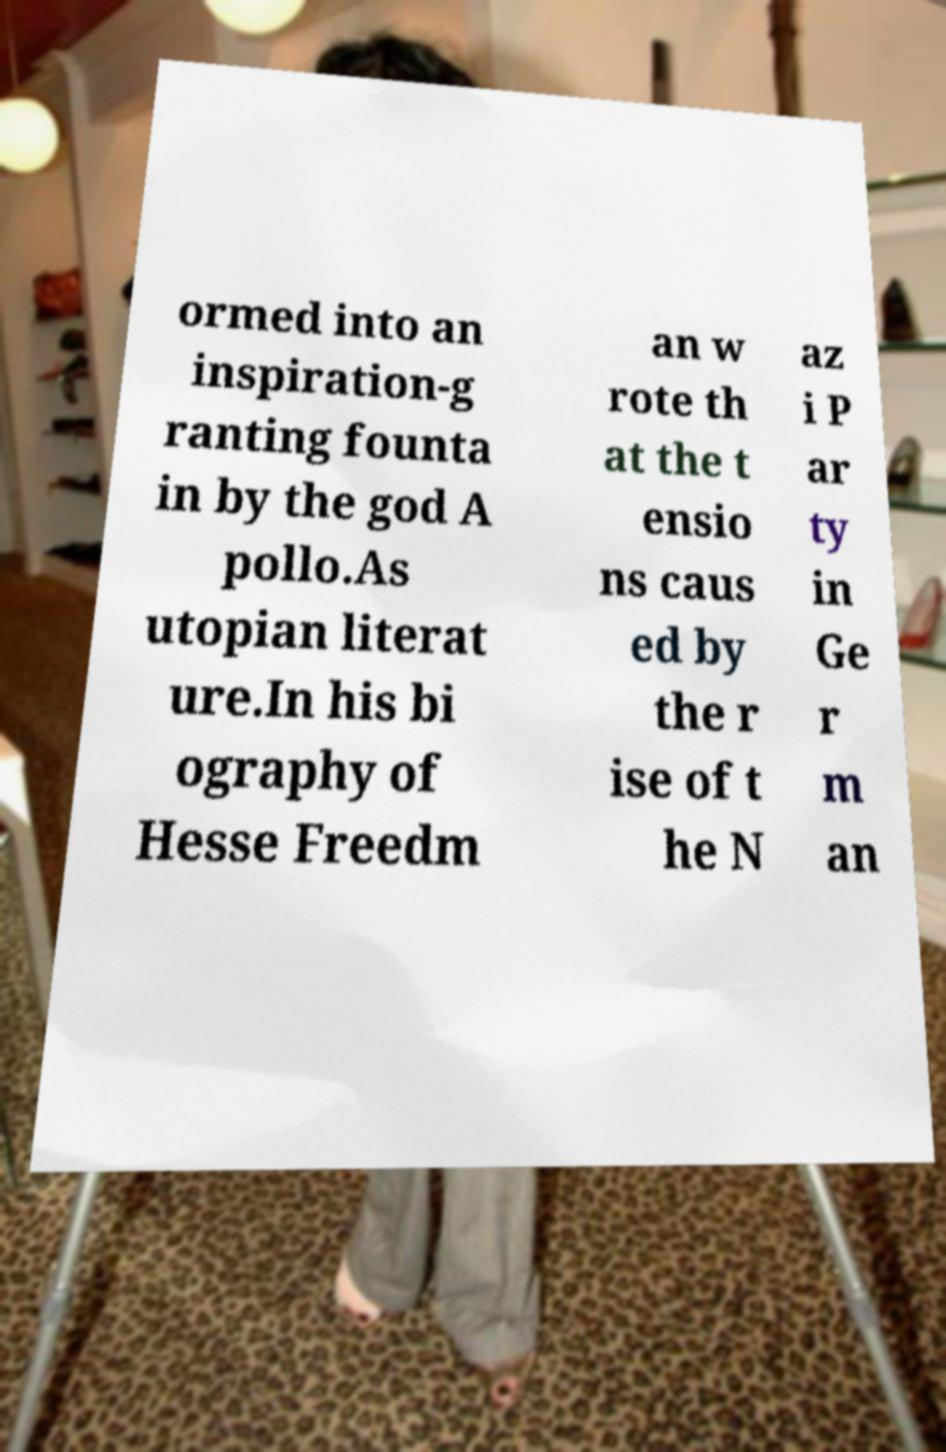Please read and relay the text visible in this image. What does it say? ormed into an inspiration-g ranting founta in by the god A pollo.As utopian literat ure.In his bi ography of Hesse Freedm an w rote th at the t ensio ns caus ed by the r ise of t he N az i P ar ty in Ge r m an 